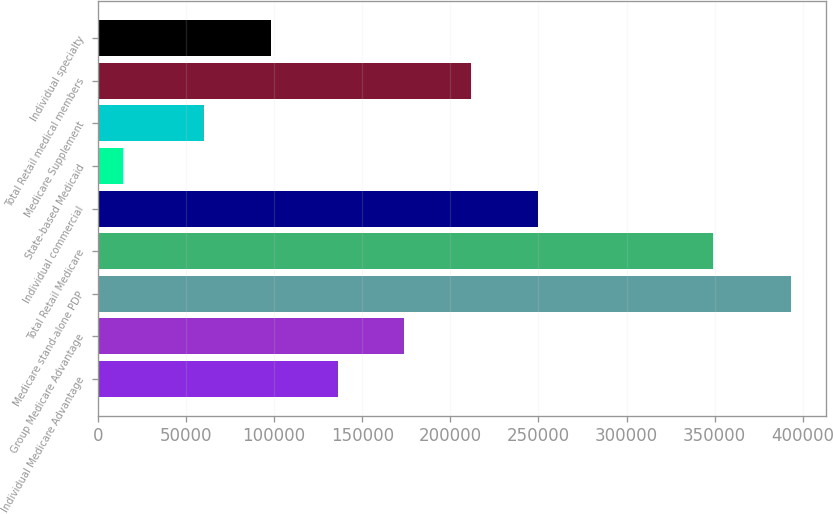<chart> <loc_0><loc_0><loc_500><loc_500><bar_chart><fcel>Individual Medicare Advantage<fcel>Group Medicare Advantage<fcel>Medicare stand-alone PDP<fcel>Total Retail Medicare<fcel>Individual commercial<fcel>State-based Medicaid<fcel>Medicare Supplement<fcel>Total Retail medical members<fcel>Individual specialty<nl><fcel>136020<fcel>173930<fcel>393500<fcel>349000<fcel>249750<fcel>14400<fcel>60200<fcel>211840<fcel>98110<nl></chart> 